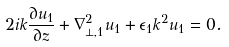Convert formula to latex. <formula><loc_0><loc_0><loc_500><loc_500>2 i k \frac { \partial u _ { 1 } } { \partial z } + \nabla _ { \perp , 1 } ^ { 2 } u _ { 1 } + \epsilon _ { 1 } k ^ { 2 } u _ { 1 } = 0 .</formula> 